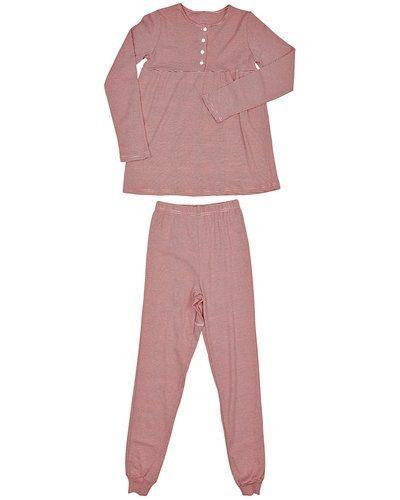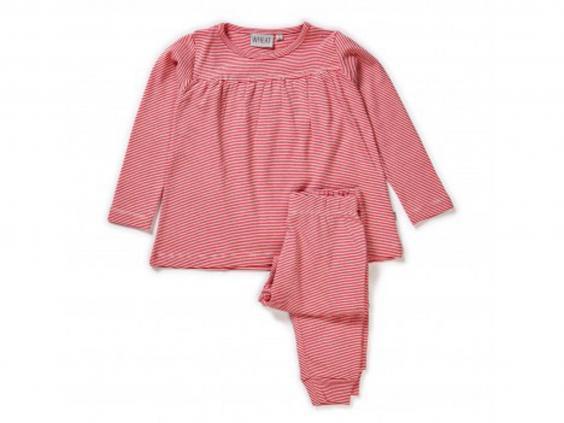The first image is the image on the left, the second image is the image on the right. Given the left and right images, does the statement "An image shows a set of loungewear that features a mostly solid-colored long-sleeved top and a coordinating pair of patterned leggings." hold true? Answer yes or no. No. 